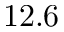<formula> <loc_0><loc_0><loc_500><loc_500>1 2 . 6</formula> 